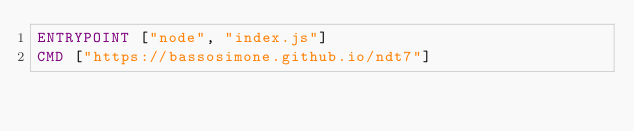Convert code to text. <code><loc_0><loc_0><loc_500><loc_500><_Dockerfile_>ENTRYPOINT ["node", "index.js"]
CMD ["https://bassosimone.github.io/ndt7"]
</code> 